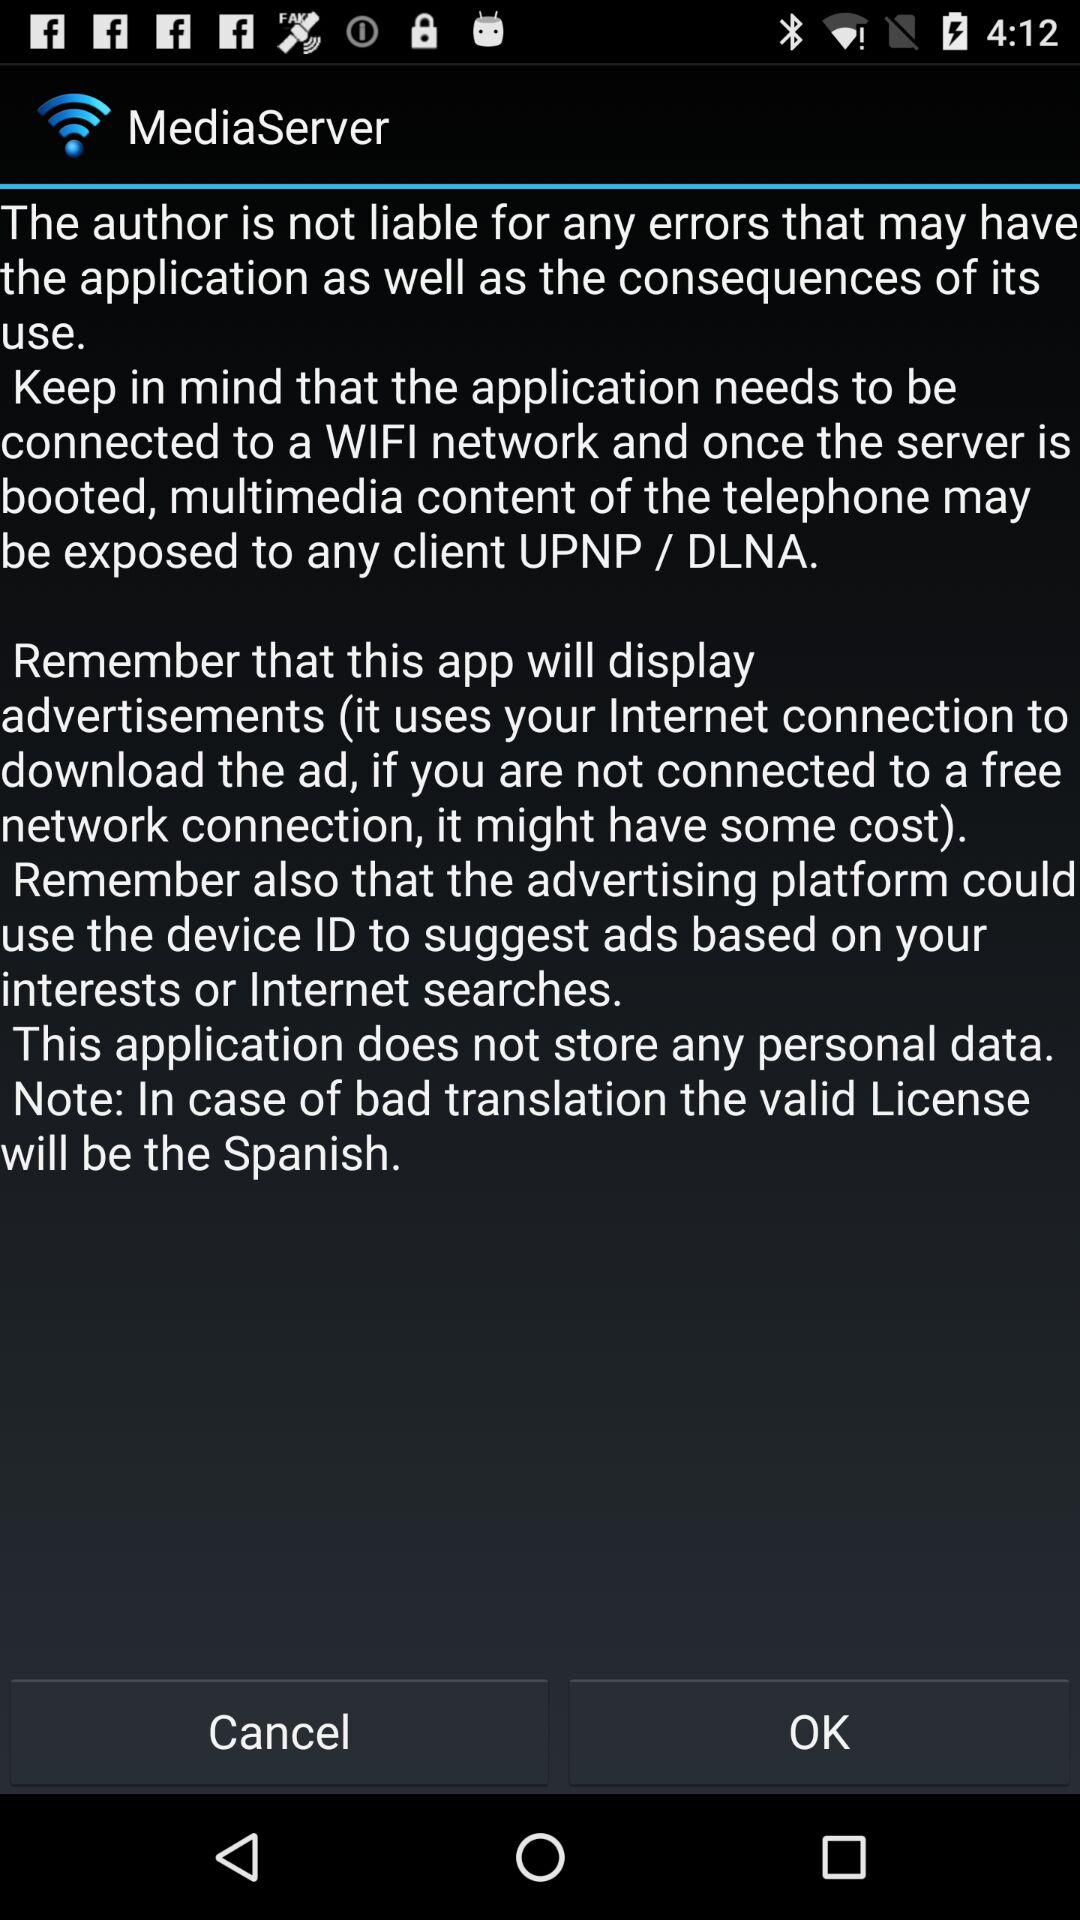When can the multimedia content of the telephone be exposed to a client? The multimedia content of the telephone can be exposed to a client when the application is connected to a WiFi network and the server is booted. 